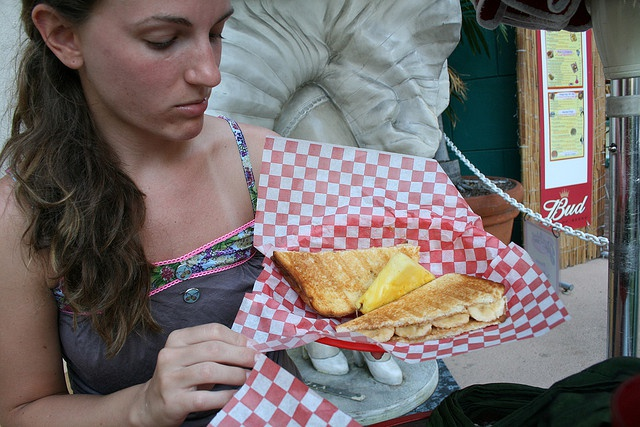Describe the objects in this image and their specific colors. I can see people in darkgray, black, and gray tones, sandwich in darkgray, tan, and khaki tones, sandwich in darkgray, tan, and brown tones, potted plant in darkgray, black, brown, gray, and maroon tones, and banana in darkgray, beige, lightgray, and tan tones in this image. 